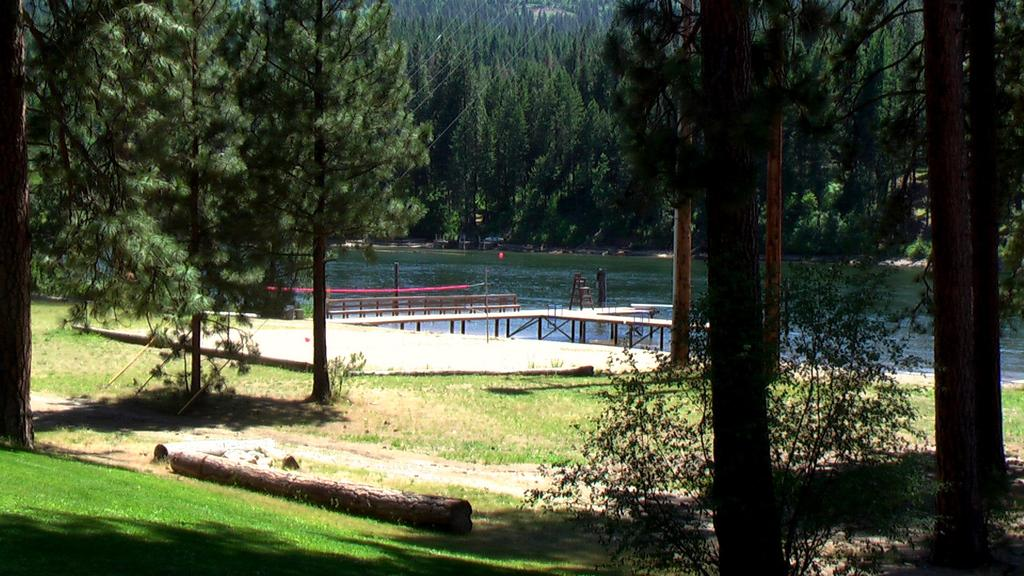What type of vegetation can be seen in the image? There are many trees, plants, and grass visible in the image. What is the wooden log used for in the image? The wooden log's purpose is not explicitly stated in the image, but it could be used for various purposes such as seating or decoration. What is the water visible in the image used for? The water in the image could be a river, lake, or pond, and it might be used for recreational activities, irrigation, or as a habitat for aquatic life. What structure is present in the image that allows people to cross the water? There is a bridge in the image that allows people to cross the water. What type of baseball can be seen in the image? There is no baseball present in the image; it features trees, plants, grass, a wooden log, water, and a bridge. 